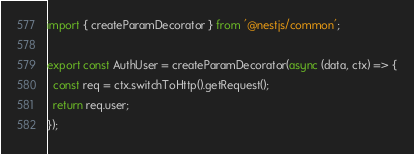Convert code to text. <code><loc_0><loc_0><loc_500><loc_500><_TypeScript_>import { createParamDecorator } from '@nestjs/common';

export const AuthUser = createParamDecorator(async (data, ctx) => {
  const req = ctx.switchToHttp().getRequest();
  return req.user;
});
</code> 